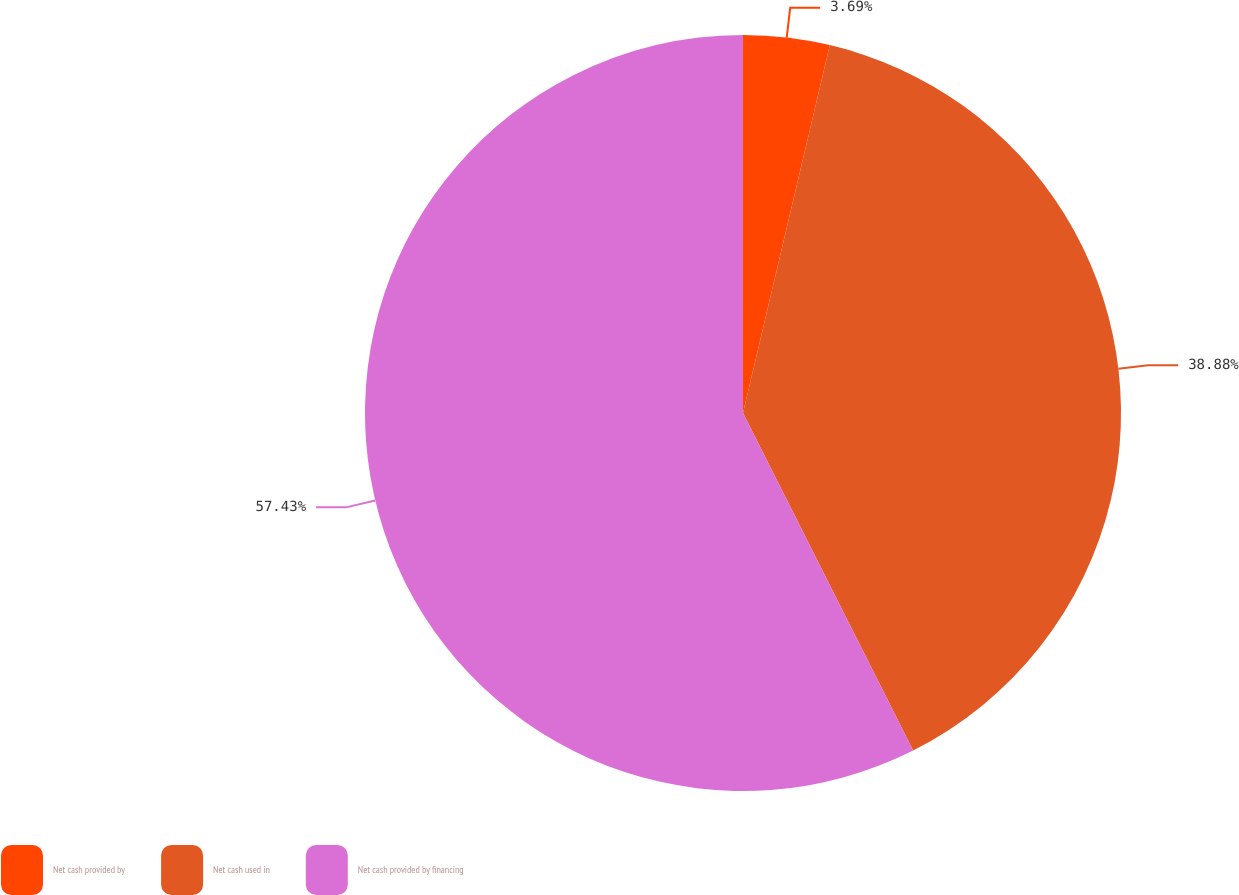Convert chart. <chart><loc_0><loc_0><loc_500><loc_500><pie_chart><fcel>Net cash provided by<fcel>Net cash used in<fcel>Net cash provided by financing<nl><fcel>3.69%<fcel>38.88%<fcel>57.43%<nl></chart> 